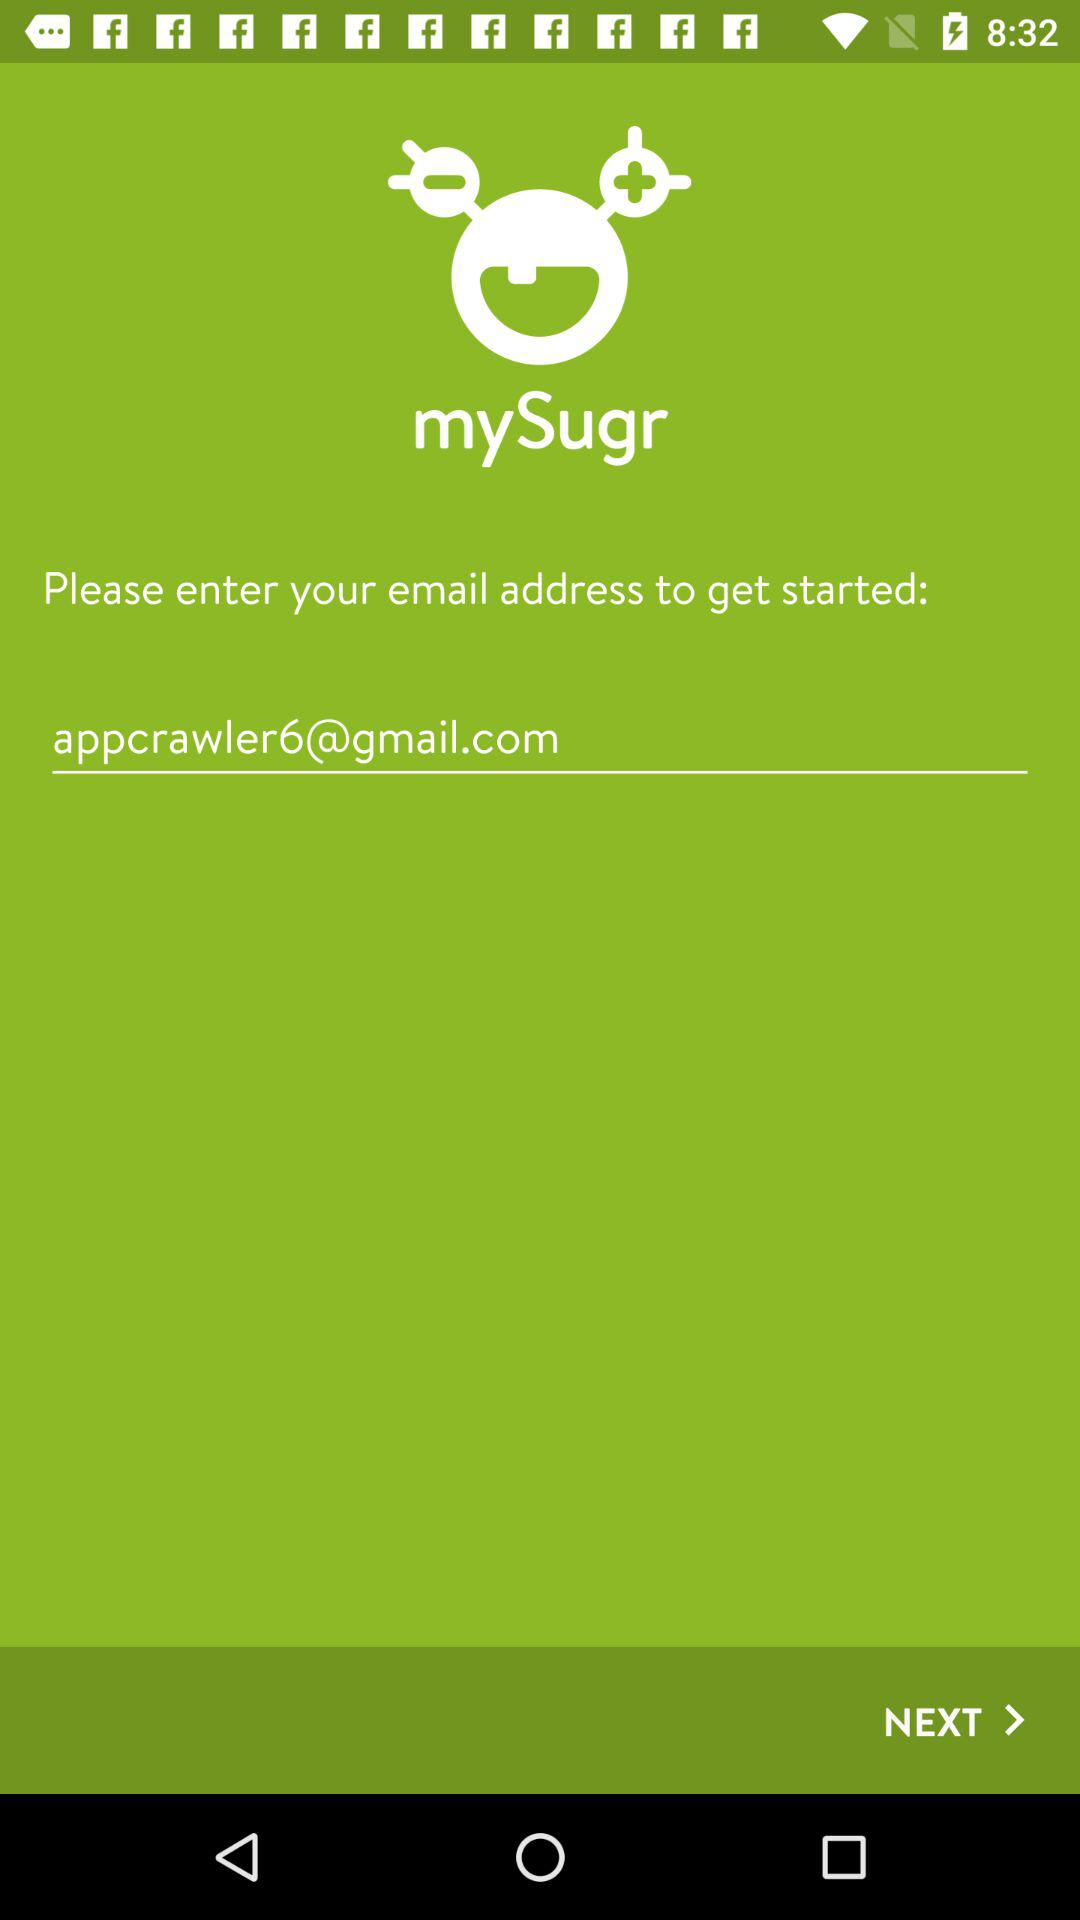How do I go to the next page?
When the provided information is insufficient, respond with <no answer>. <no answer> 